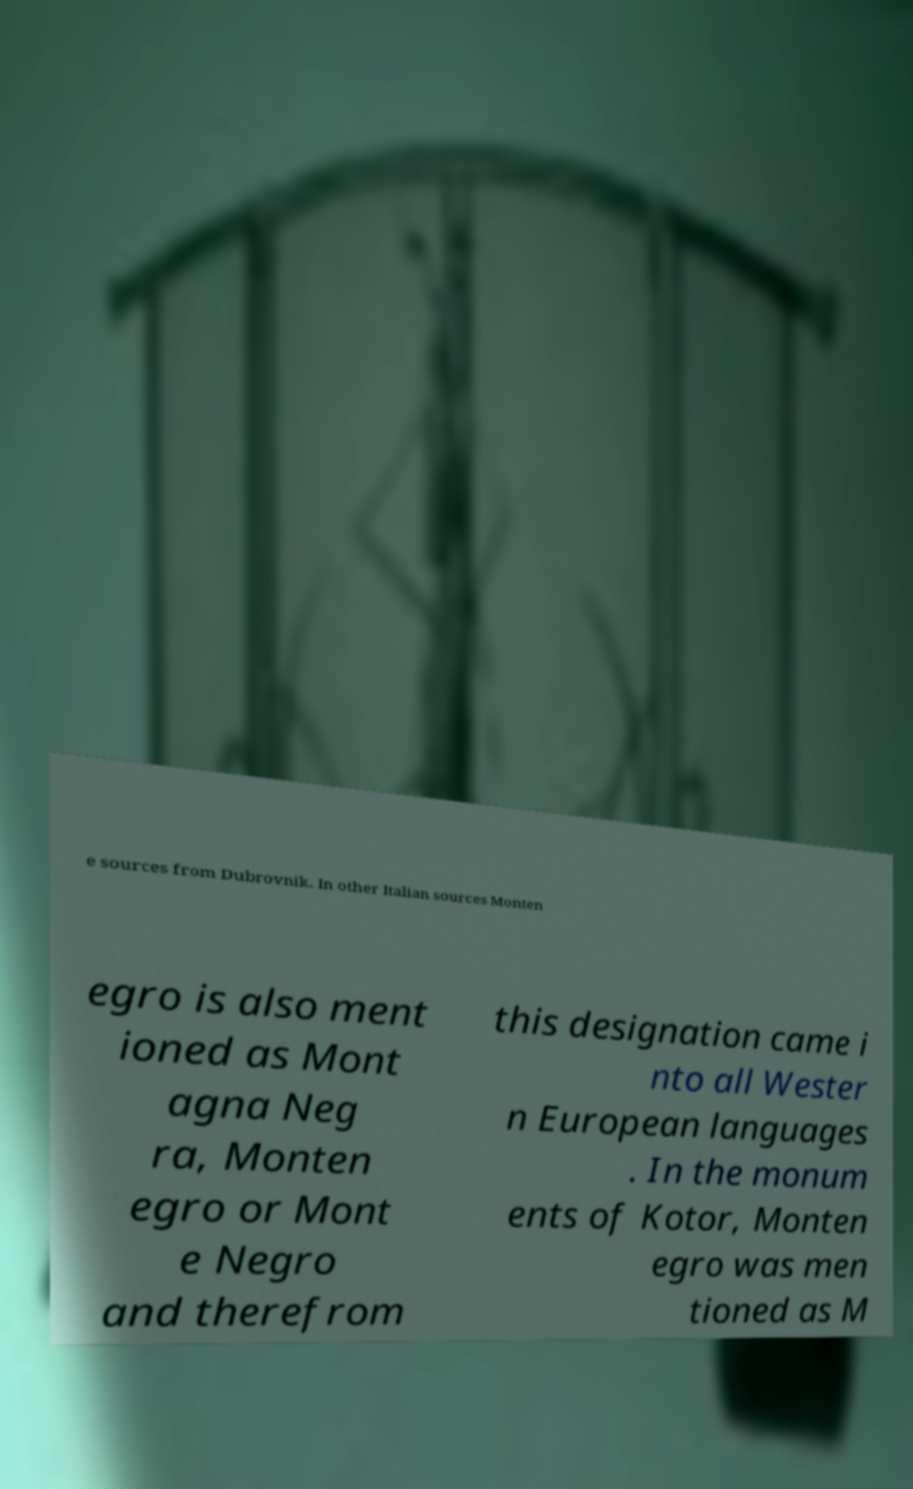Please identify and transcribe the text found in this image. e sources from Dubrovnik. In other Italian sources Monten egro is also ment ioned as Mont agna Neg ra, Monten egro or Mont e Negro and therefrom this designation came i nto all Wester n European languages . In the monum ents of Kotor, Monten egro was men tioned as M 